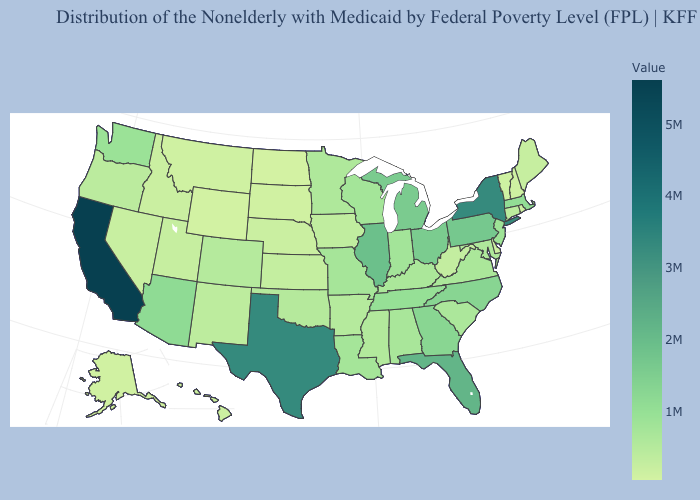Does Illinois have the highest value in the MidWest?
Be succinct. Yes. Among the states that border Connecticut , does Rhode Island have the lowest value?
Be succinct. Yes. Among the states that border Michigan , does Ohio have the highest value?
Give a very brief answer. Yes. Among the states that border Maryland , which have the lowest value?
Write a very short answer. Delaware. Does Connecticut have the highest value in the Northeast?
Give a very brief answer. No. Does Ohio have the highest value in the USA?
Give a very brief answer. No. Does North Dakota have the lowest value in the USA?
Answer briefly. Yes. Does North Dakota have the lowest value in the MidWest?
Keep it brief. Yes. Which states hav the highest value in the South?
Give a very brief answer. Texas. Does Minnesota have a lower value than North Dakota?
Short answer required. No. 